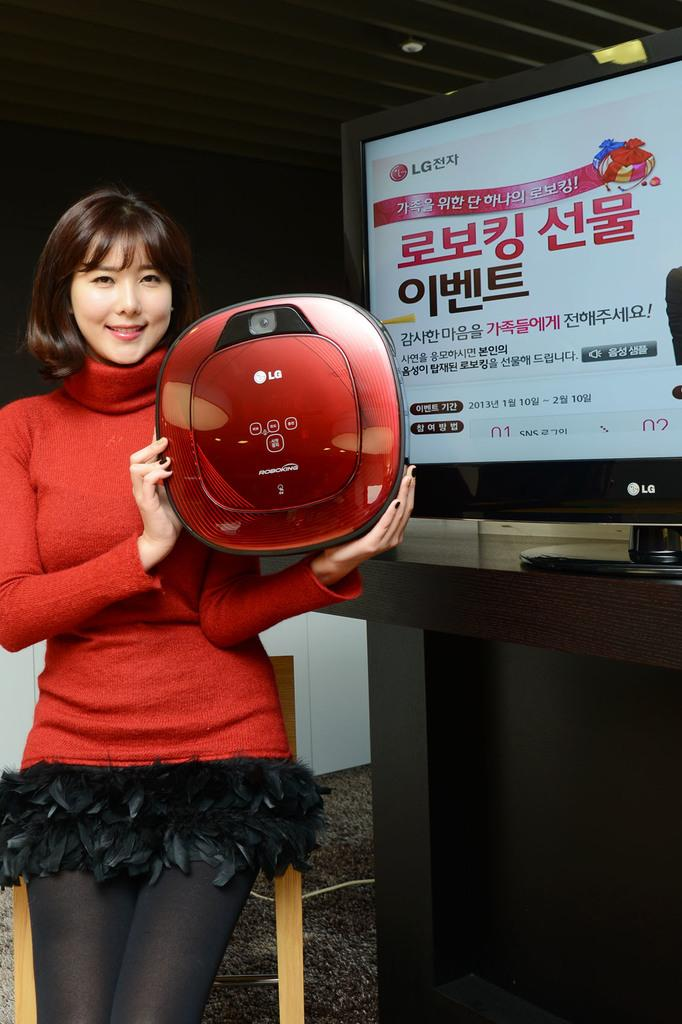What is the woman doing in the image? The woman is standing in the image. What is the woman holding in the image? The woman is holding an object. What can be seen on a piece of furniture in the image? There is a television on a table in the image. What is visible in the background of the image? There is a wall visible in the background of the image. Is the woman standing in a cave in the image? No, there is no cave present in the image. What type of winter clothing is the woman wearing in the image? There is no winter clothing mentioned in the image, as it does not reference any specific season or weather conditions. 